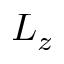<formula> <loc_0><loc_0><loc_500><loc_500>L _ { z }</formula> 